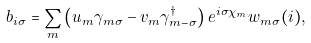Convert formula to latex. <formula><loc_0><loc_0><loc_500><loc_500>b _ { i \sigma } = \sum _ { m } \left ( u _ { m } \gamma _ { m \sigma } - v _ { m } \gamma ^ { \dagger } _ { m - \sigma } \right ) e ^ { i \sigma \chi _ { m } } w _ { m \sigma } ( i ) ,</formula> 